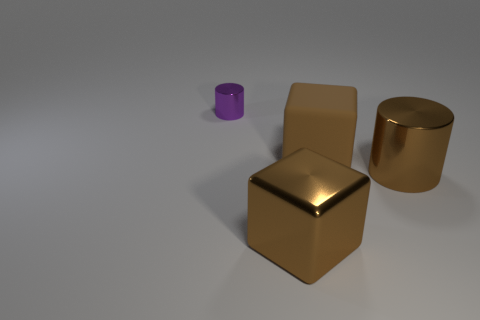There is a cube that is the same color as the rubber object; what is it made of?
Ensure brevity in your answer.  Metal. Are there any other things that are the same size as the purple metal thing?
Provide a short and direct response. No. Are there fewer big yellow shiny cylinders than big brown metallic blocks?
Ensure brevity in your answer.  Yes. How many metallic objects are either blocks or tiny purple cylinders?
Keep it short and to the point. 2. Is there a small purple object behind the large brown metallic object behind the large brown metallic cube?
Provide a short and direct response. Yes. Is the material of the cylinder that is in front of the small thing the same as the tiny purple object?
Your answer should be very brief. Yes. What number of other objects are the same color as the big rubber cube?
Keep it short and to the point. 2. Does the big rubber object have the same color as the big cylinder?
Ensure brevity in your answer.  Yes. There is a brown object in front of the cylinder in front of the purple thing; what is its size?
Give a very brief answer. Large. Does the brown thing in front of the large brown cylinder have the same material as the cube to the right of the big shiny cube?
Provide a succinct answer. No. 